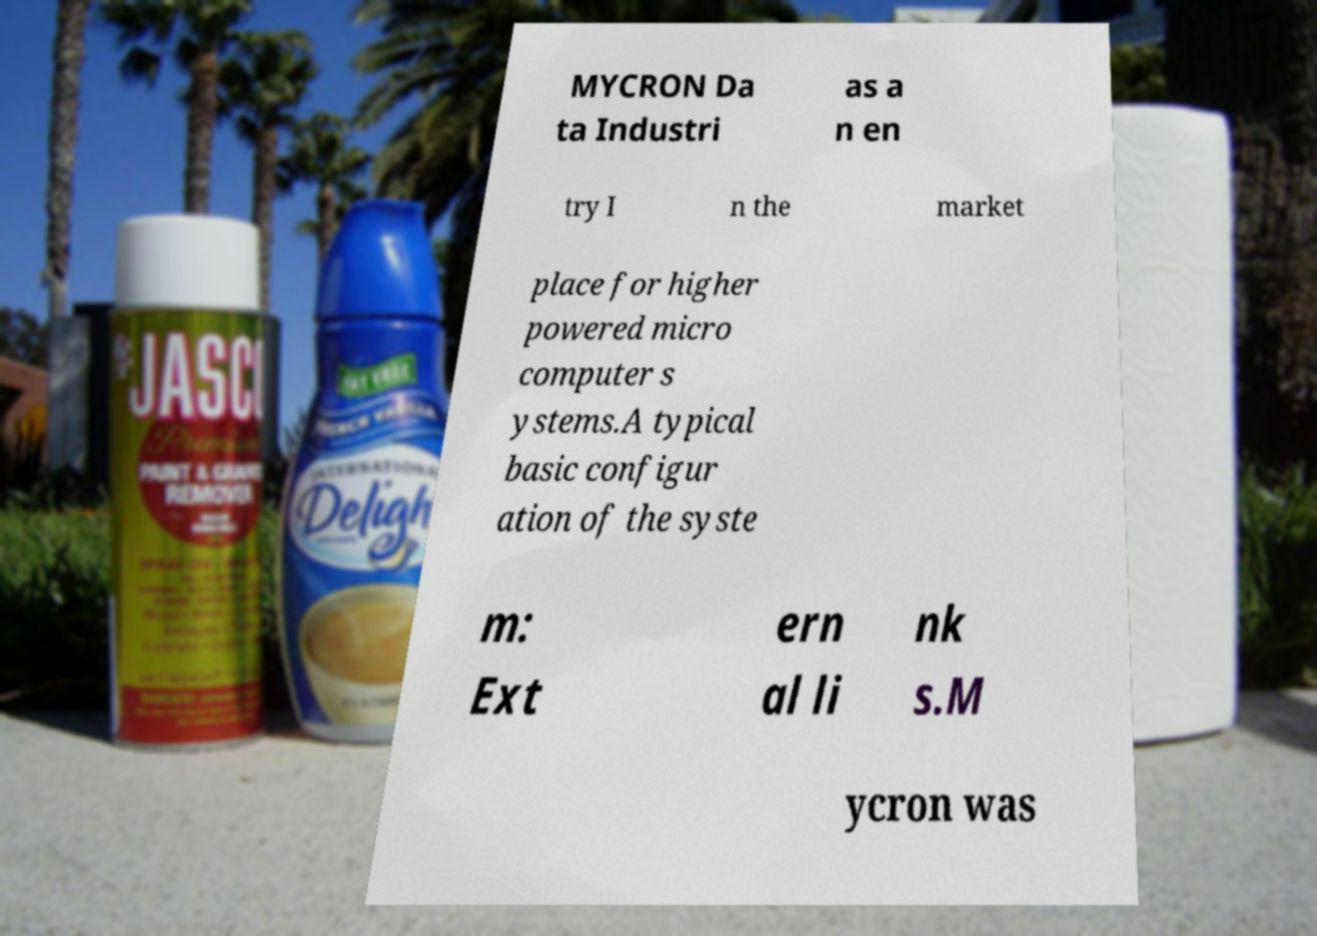For documentation purposes, I need the text within this image transcribed. Could you provide that? MYCRON Da ta Industri as a n en try I n the market place for higher powered micro computer s ystems.A typical basic configur ation of the syste m: Ext ern al li nk s.M ycron was 